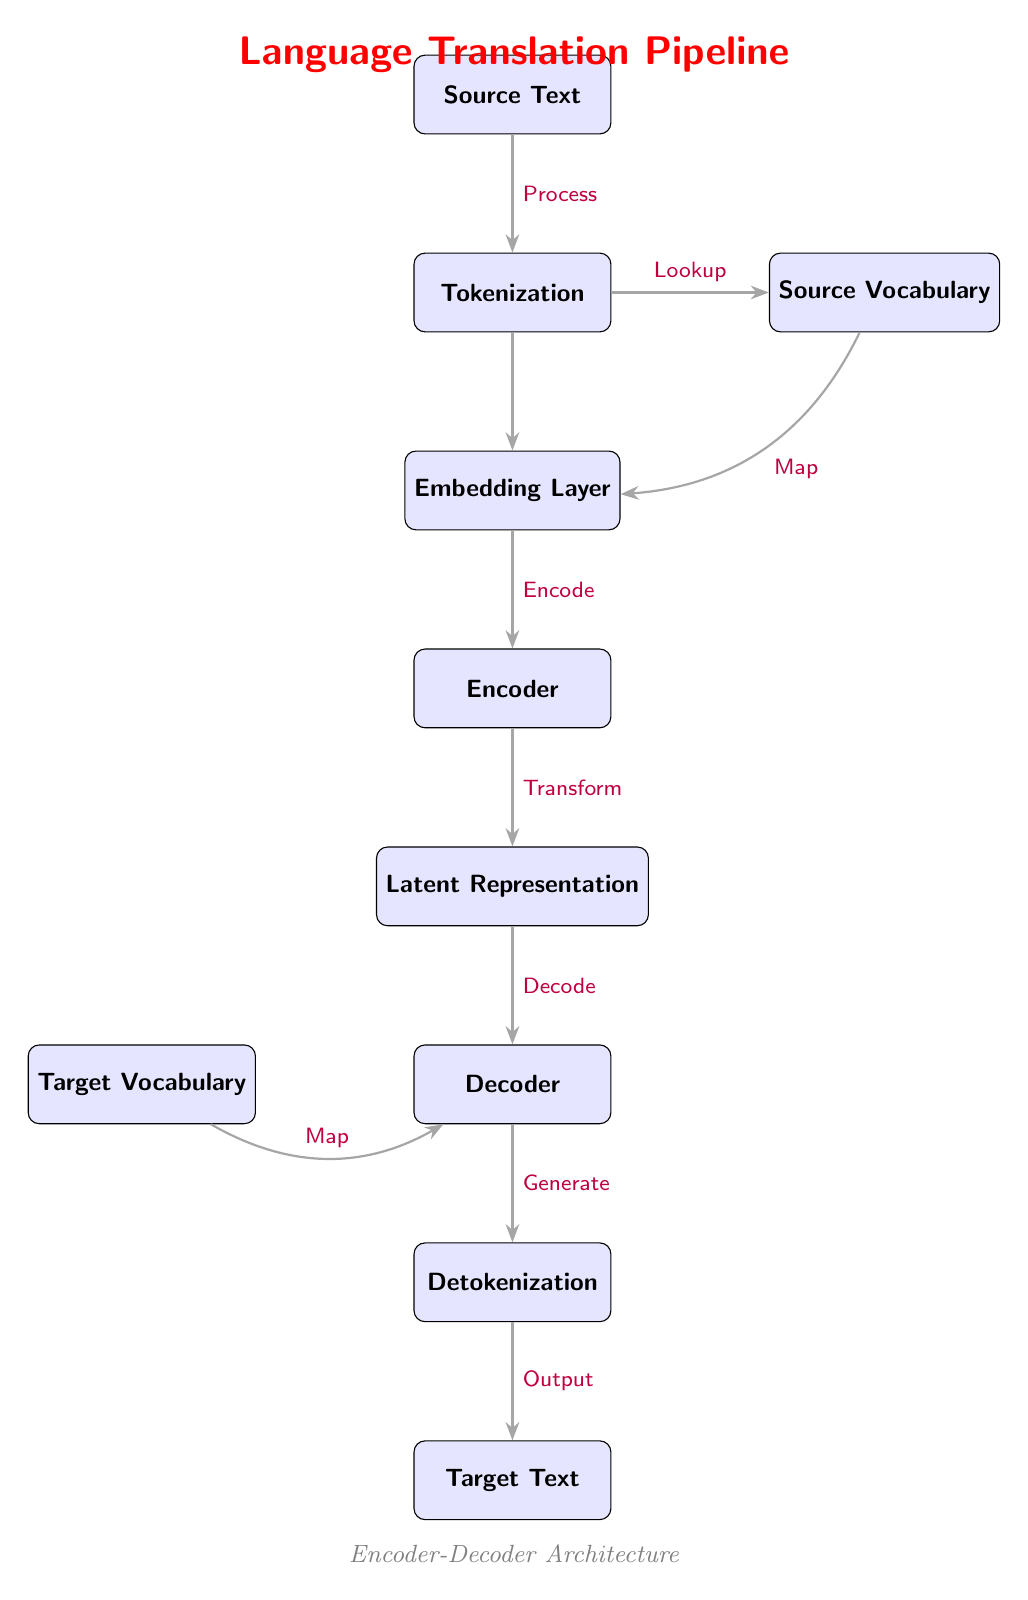What is the starting point of the language translation pipeline? The starting point is the "Source Text" node, which is the initial input for the entire pipeline.
Answer: Source Text How many nodes are in the diagram? By counting the boxes, we can see that there are a total of 10 nodes in the diagram.
Answer: 10 What does the "Tokenization" process lead to? The "Tokenization" process directly leads to two outcomes: it creates a "Source Vocabulary" through a lookup and also feeds into the "Embedding Layer."
Answer: Source Vocabulary, Embedding Layer What is the function of the "Encoder"? The "Encoder" takes the "Embedding Layer" output and converts it into a "Latent Representation," making it essential for transforming the input data into a format suitable for decoding.
Answer: Latent Representation How does the "Decoder" connect to the "Target Vocabulary"? The "Decoder" obtains information from the "Target Vocabulary" through a mapping process, which aids in generating the output during translation.
Answer: Map What is the final output of the pipeline? The final output of the language translation pipeline is the "Target Text," which is produced after the "Detokenization" process.
Answer: Target Text Which two nodes are involved in the generation of output? The two nodes involved in the generation of output are the "Decoder" and "Detokenization," as they work together to produce the final "Target Text."
Answer: Decoder, Detokenization Explain how the transformation from "Encoder" to "Latent Representation" occurs. The "Encoder" processes the input data from the "Embedding Layer," applying transformations that convert this data representation into a "Latent Representation," which is a compact form capturing the essence of the source input for decoding.
Answer: Transformation What role does the "Detokenization" process play in the flow? "Detokenization" is crucial as it takes the output from the "Decoder" and converts language pieces back into a coherent "Target Text," making it a significant step before the final output is produced.
Answer: Convert language pieces back 